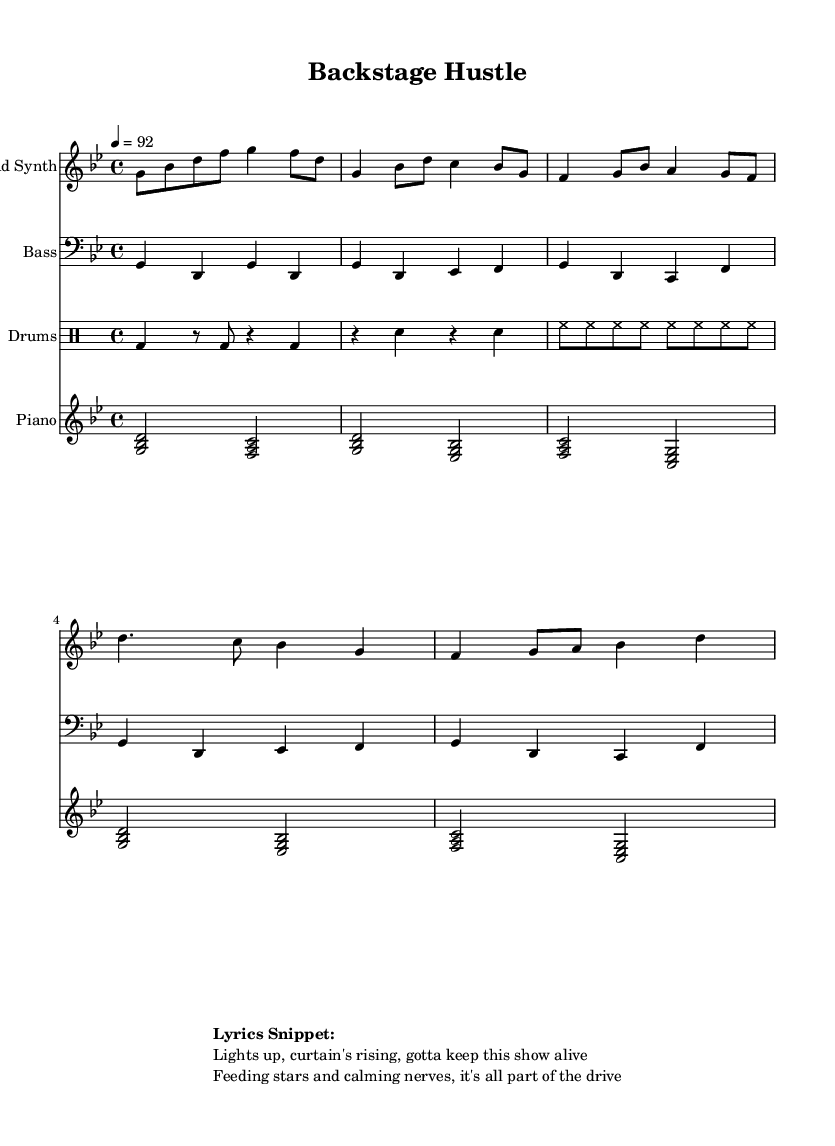What is the key signature of this music? The key signature is indicated at the beginning of the music. In this case, it is G minor, which has two flats (B flat and E flat).
Answer: G minor What is the time signature of this music? The time signature is found at the start of the music. Here, it is 4/4, which means there are four beats in a measure and a quarter note gets one beat.
Answer: 4/4 What is the tempo of this music? The tempo is specified within the global settings of the score. It indicates a speed of 92 beats per minute, suggesting a moderate tempo suitable for hip hop tracks.
Answer: 92 How many instruments are used in this piece? The score lists four different staves: Lead Synth, Bass, Drums, and Piano. Each staff represents a different instrument, indicating that there are four instruments in total.
Answer: Four Which section of the music contains the lyrics snippet? The lyrics snippet is highlighted in the markup section at the bottom of the score. It shows the text that accompanies the music and refers to the overall theme of managing a busy theater during performances.
Answer: Lyrics snippet What is the mood conveyed by the lyrics snippet? The lyrics snippet expresses themes of excitement and responsibility, indicating the hustle and drive required to manage a theater successfully. The terms used suggest a positive and energetic atmosphere fitting for an upbeat hip hop track.
Answer: Positive 